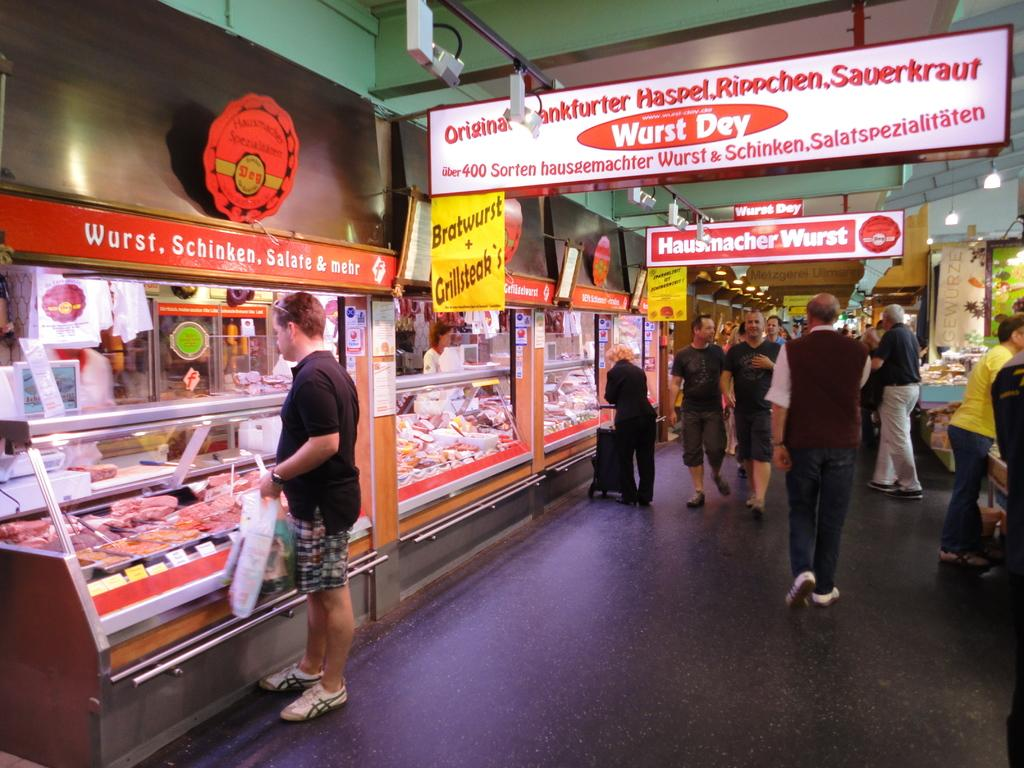<image>
Create a compact narrative representing the image presented. People are shopping at Wurst Day, a store that sells Bratwurst and Sauerkraut. 